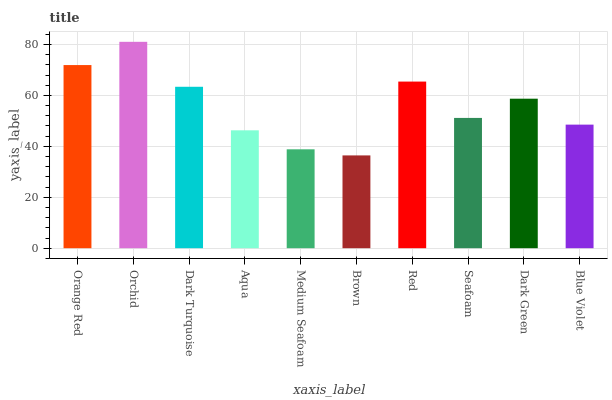Is Brown the minimum?
Answer yes or no. Yes. Is Orchid the maximum?
Answer yes or no. Yes. Is Dark Turquoise the minimum?
Answer yes or no. No. Is Dark Turquoise the maximum?
Answer yes or no. No. Is Orchid greater than Dark Turquoise?
Answer yes or no. Yes. Is Dark Turquoise less than Orchid?
Answer yes or no. Yes. Is Dark Turquoise greater than Orchid?
Answer yes or no. No. Is Orchid less than Dark Turquoise?
Answer yes or no. No. Is Dark Green the high median?
Answer yes or no. Yes. Is Seafoam the low median?
Answer yes or no. Yes. Is Aqua the high median?
Answer yes or no. No. Is Aqua the low median?
Answer yes or no. No. 